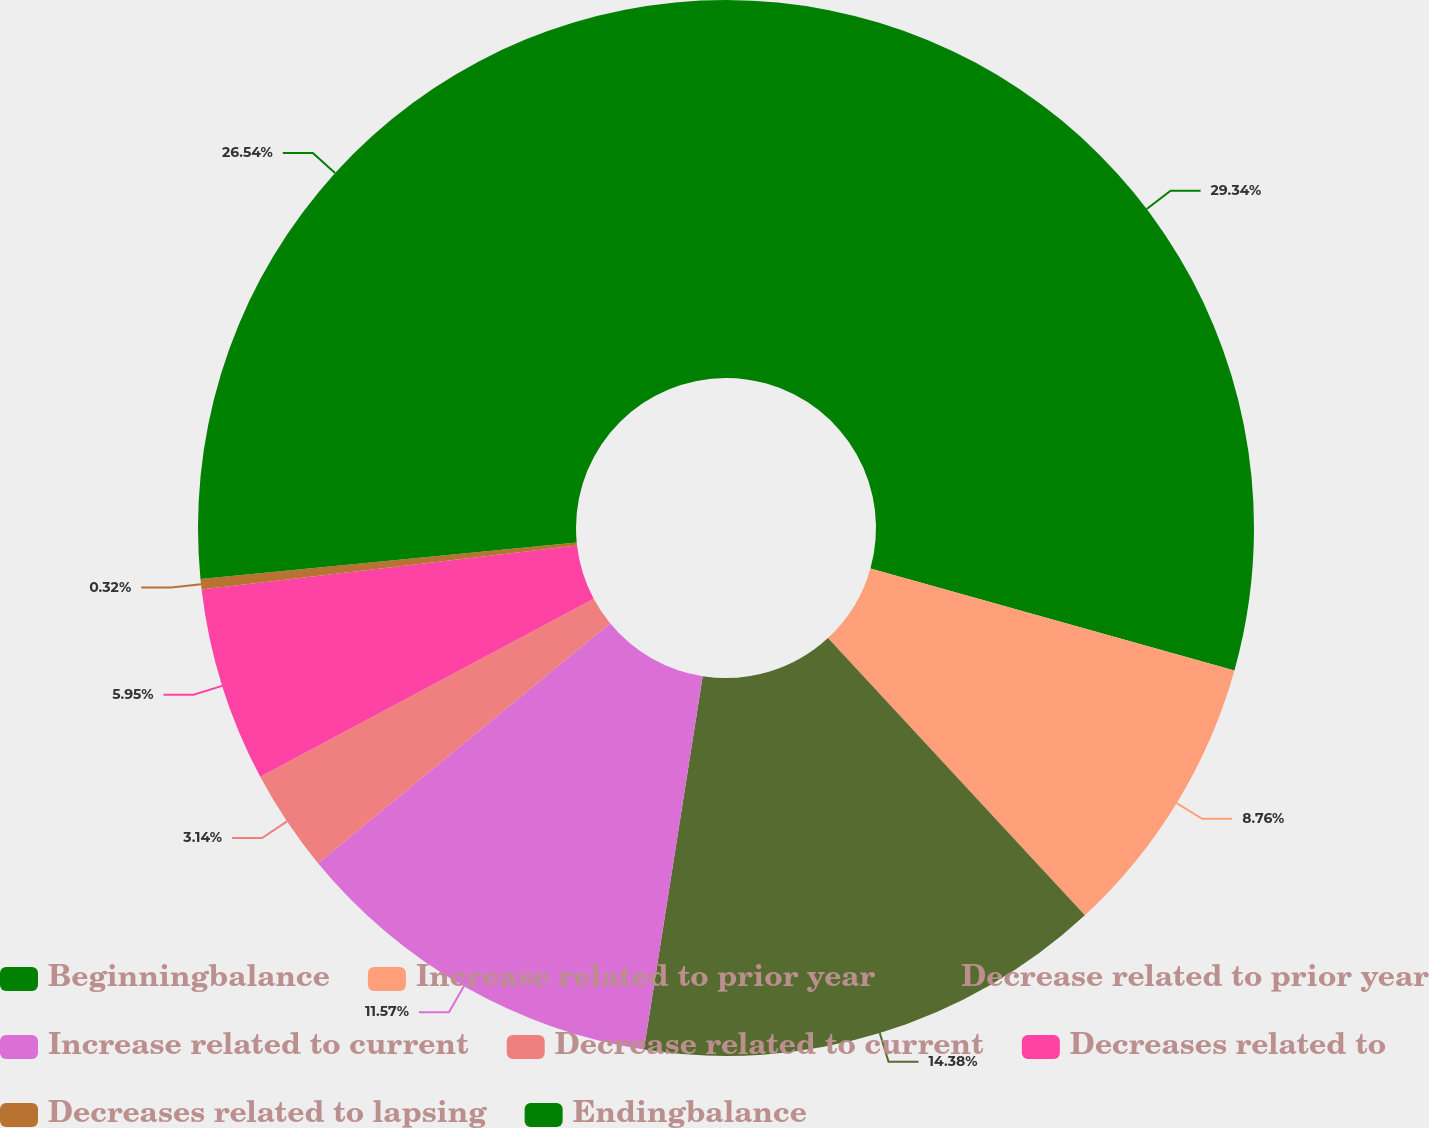Convert chart to OTSL. <chart><loc_0><loc_0><loc_500><loc_500><pie_chart><fcel>Beginningbalance<fcel>Increase related to prior year<fcel>Decrease related to prior year<fcel>Increase related to current<fcel>Decrease related to current<fcel>Decreases related to<fcel>Decreases related to lapsing<fcel>Endingbalance<nl><fcel>29.35%<fcel>8.76%<fcel>14.38%<fcel>11.57%<fcel>3.14%<fcel>5.95%<fcel>0.32%<fcel>26.54%<nl></chart> 